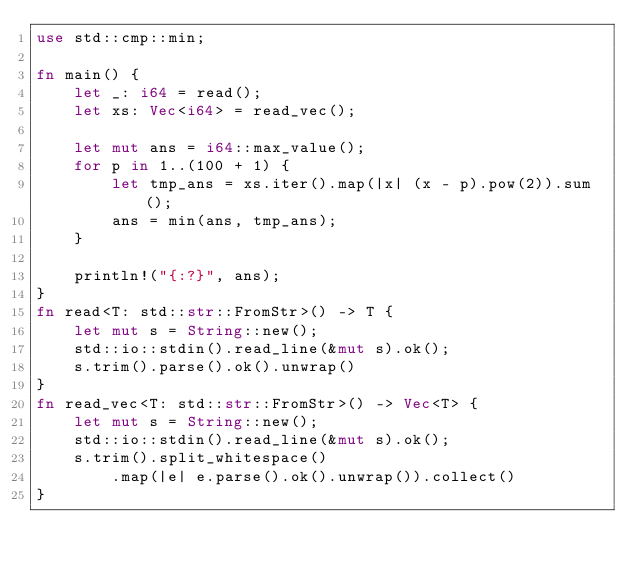Convert code to text. <code><loc_0><loc_0><loc_500><loc_500><_Rust_>use std::cmp::min;

fn main() {
    let _: i64 = read();
    let xs: Vec<i64> = read_vec();

    let mut ans = i64::max_value();
    for p in 1..(100 + 1) {
        let tmp_ans = xs.iter().map(|x| (x - p).pow(2)).sum();
        ans = min(ans, tmp_ans);
    }

    println!("{:?}", ans);
}
fn read<T: std::str::FromStr>() -> T {
    let mut s = String::new();
    std::io::stdin().read_line(&mut s).ok();
    s.trim().parse().ok().unwrap()
}
fn read_vec<T: std::str::FromStr>() -> Vec<T> {
    let mut s = String::new();
    std::io::stdin().read_line(&mut s).ok();
    s.trim().split_whitespace()
        .map(|e| e.parse().ok().unwrap()).collect()
}

</code> 